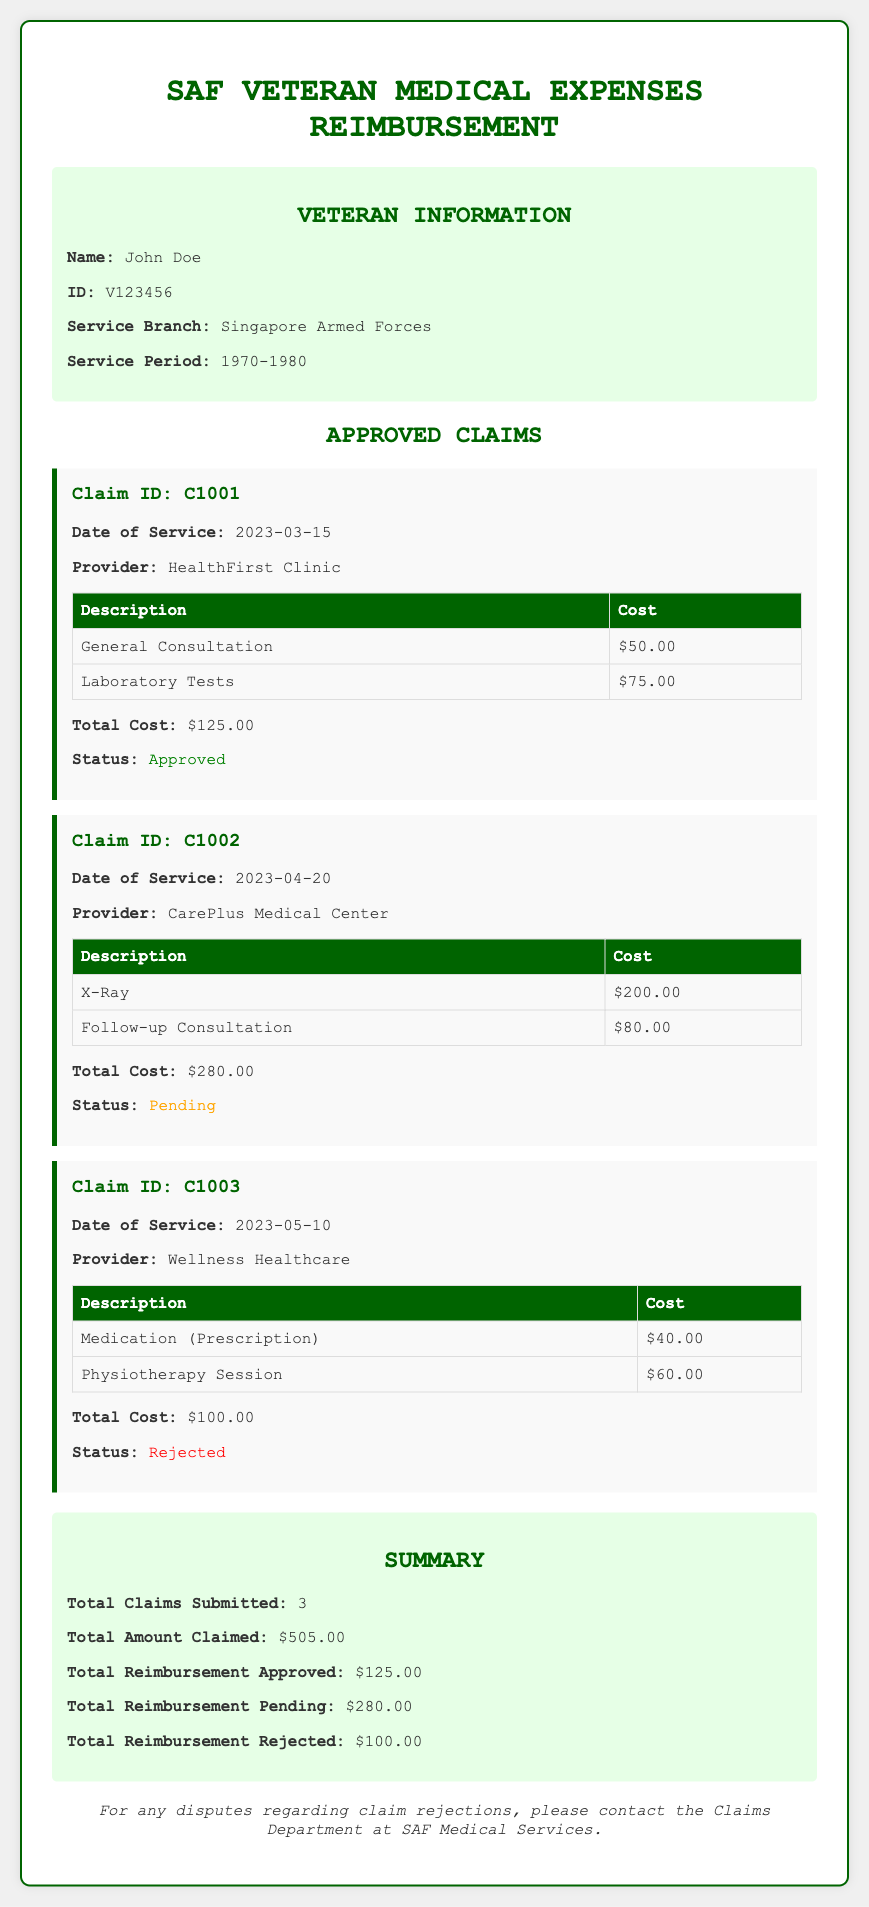What is the veteran's name? The document states that the veteran's name is John Doe.
Answer: John Doe What is the total amount claimed? The document summarizes the total amount claimed as $505.00.
Answer: $505.00 What is the status of Claim ID C1002? The document indicates that Claim ID C1002 has a status of Pending.
Answer: Pending How much was approved for reimbursement? The summary section states that the total reimbursement approved is $125.00.
Answer: $125.00 What was the date of service for Claim ID C1001? The document lists the date of service for Claim ID C1001 as 2023-03-15.
Answer: 2023-03-15 What services were provided by HealthFirst Clinic? The claim narrative details that the services were General Consultation and Laboratory Tests.
Answer: General Consultation, Laboratory Tests How much was the cost for the X-Ray? The document specifies that the cost for the X-Ray is $200.00.
Answer: $200.00 What is the rejection status of Claim ID C1003? The document states that Claim ID C1003 has a status of Rejected.
Answer: Rejected What is the total reimbursement rejected? The summary indicates that the total reimbursement rejected is $100.00.
Answer: $100.00 